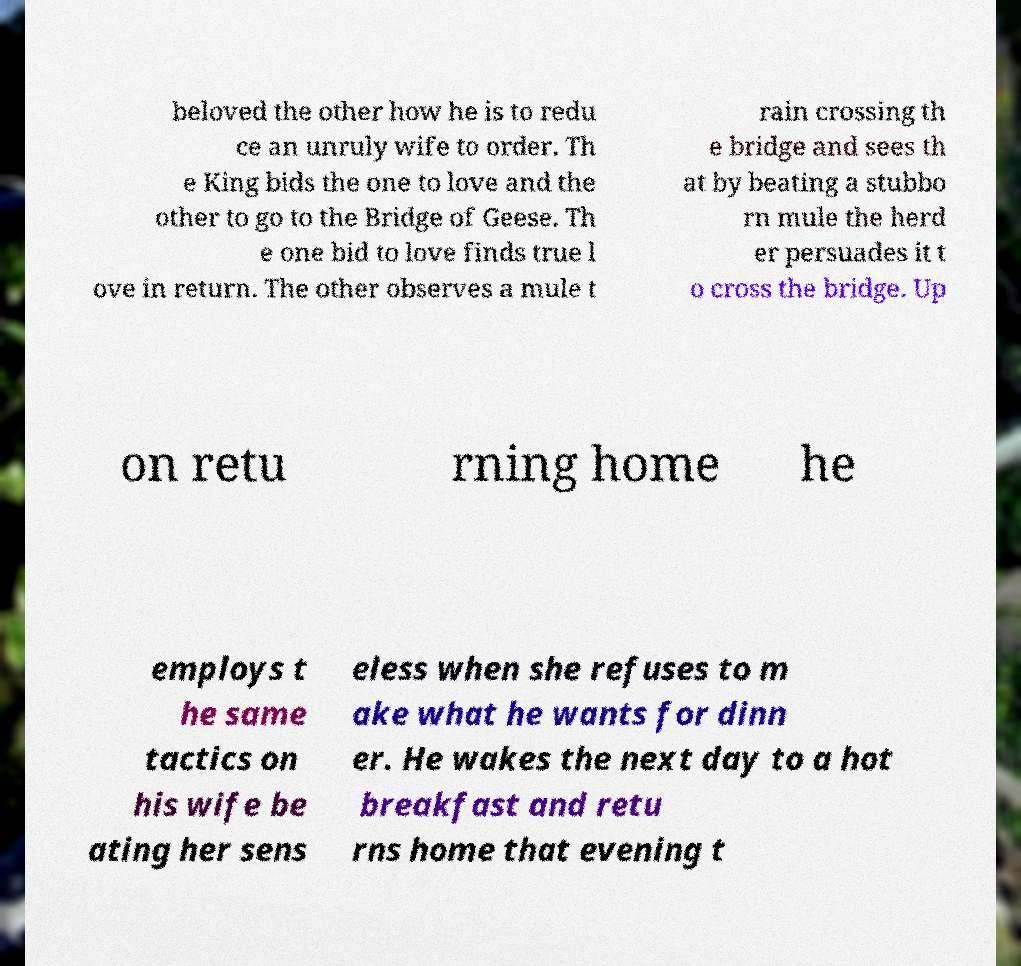I need the written content from this picture converted into text. Can you do that? beloved the other how he is to redu ce an unruly wife to order. Th e King bids the one to love and the other to go to the Bridge of Geese. Th e one bid to love finds true l ove in return. The other observes a mule t rain crossing th e bridge and sees th at by beating a stubbo rn mule the herd er persuades it t o cross the bridge. Up on retu rning home he employs t he same tactics on his wife be ating her sens eless when she refuses to m ake what he wants for dinn er. He wakes the next day to a hot breakfast and retu rns home that evening t 